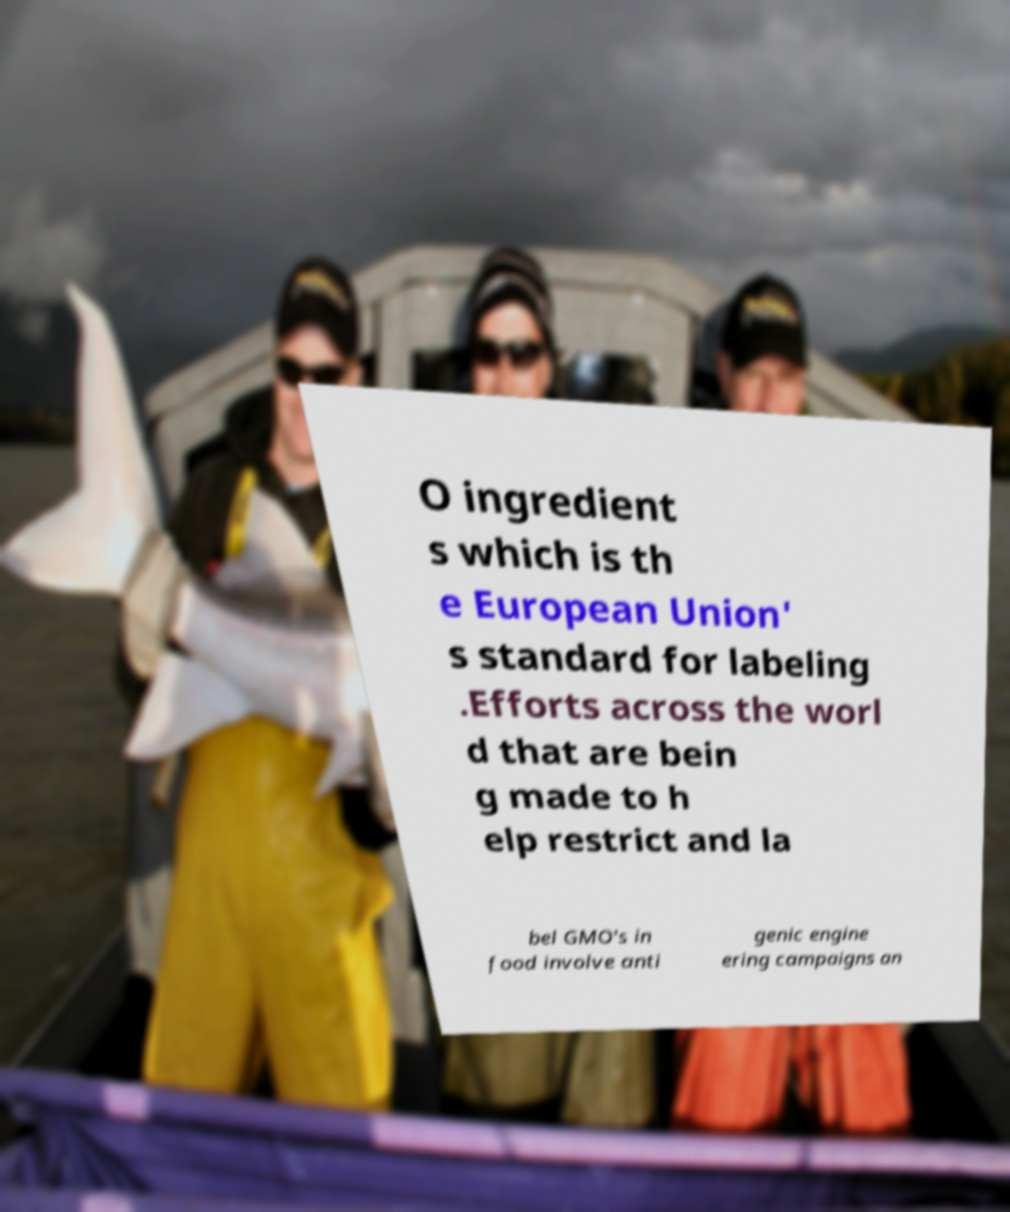Could you extract and type out the text from this image? O ingredient s which is th e European Union' s standard for labeling .Efforts across the worl d that are bein g made to h elp restrict and la bel GMO's in food involve anti genic engine ering campaigns an 